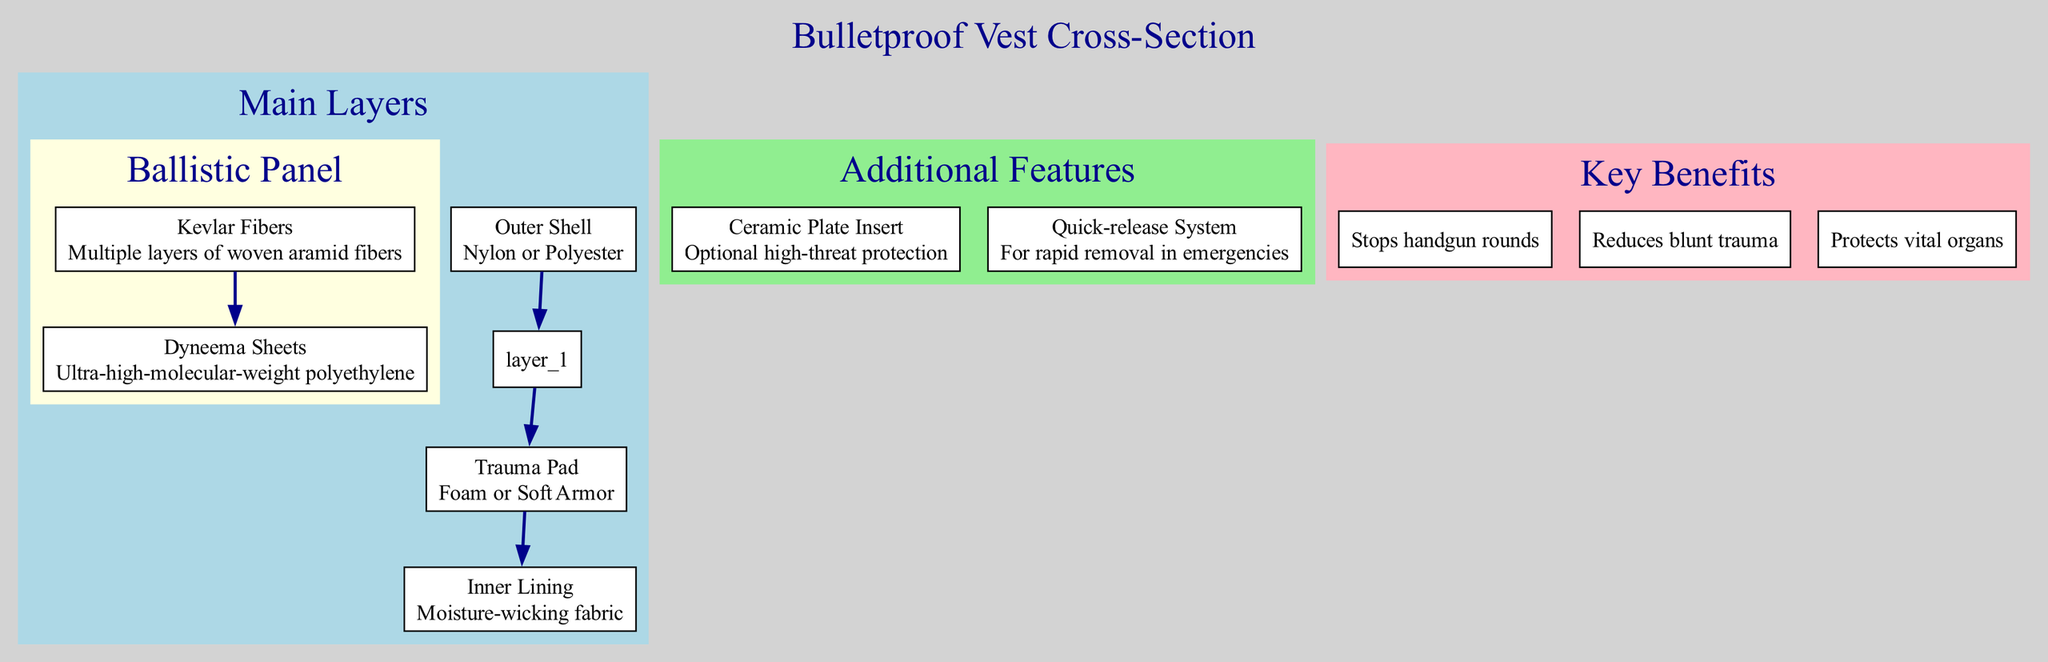What is the outer shell material of the bulletproof vest? The diagram specifies that the outer shell is made of either Nylon or Polyester. This information is directly labeled in the "Outer Shell" layer section.
Answer: Nylon or Polyester How many sub-layers are there in the ballistic panel? The ballistic panel consists of two sub-layers: Kevlar Fibers and Dyneema Sheets. Counting these sub-layers gives us the number two, as indicated in the diagram.
Answer: 2 What is the material of the trauma pad? The trauma pad is labeled as being made from either Foam or Soft Armor in the diagram. This is a clear designation within the "Trauma Pad" layer.
Answer: Foam or Soft Armor Which feature provides optional high-threat protection? The diagram identifies the "Ceramic Plate Insert" as the feature that offers optional high-threat protection. This is explicitly stated in the additional features section.
Answer: Ceramic Plate Insert What is one key benefit of wearing a bulletproof vest? One of the key benefits listed in the diagram is that it "Stops handgun rounds." This is one of the three benefits highlighted in the key benefits section.
Answer: Stops handgun rounds How many main layers are depicted in the diagram? The diagram shows four main layers: Outer Shell, Ballistic Panel, Trauma Pad, and Inner Lining. By counting these distinct layers, we find four.
Answer: 4 What materials make up the ballistic panel? The ballistic panel is composed of Kevlar Fibers and Dyneema Sheets. This information is specified in the sub-layers section under the ballistic panel.
Answer: Kevlar Fibers and Dyneema Sheets What is the purpose of the quick-release system? The quick-release system is designed for rapid removal in emergencies, as stated in the diagram's description of additional features.
Answer: Rapid removal in emergencies Explain how the trauma pad contributes to the vest's effectiveness. The trauma pad, made of Foam or Soft Armor, helps reduce blunt trauma, providing additional protection to the wearer. This function is inferred from both the material description and its placement in the vest structure.
Answer: Reduces blunt trauma 